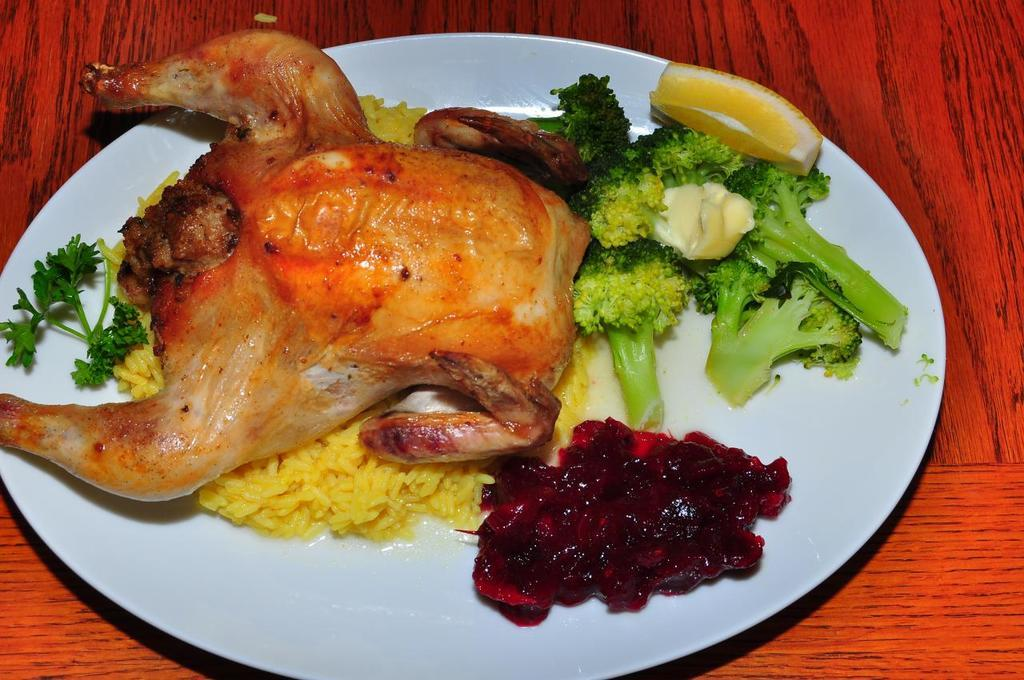What type of vegetable is present in the image? There is broccoli in the image. What type of grain is present in the image? There is rice in the image. What other food items can be seen on a plate in the image? There are other food items on a plate in the image. On what surface is the plate placed? The plate is on a wooden table. What is the profit margin of the turkey in the image? There is no turkey present in the image, so it is not possible to determine the profit margin. 